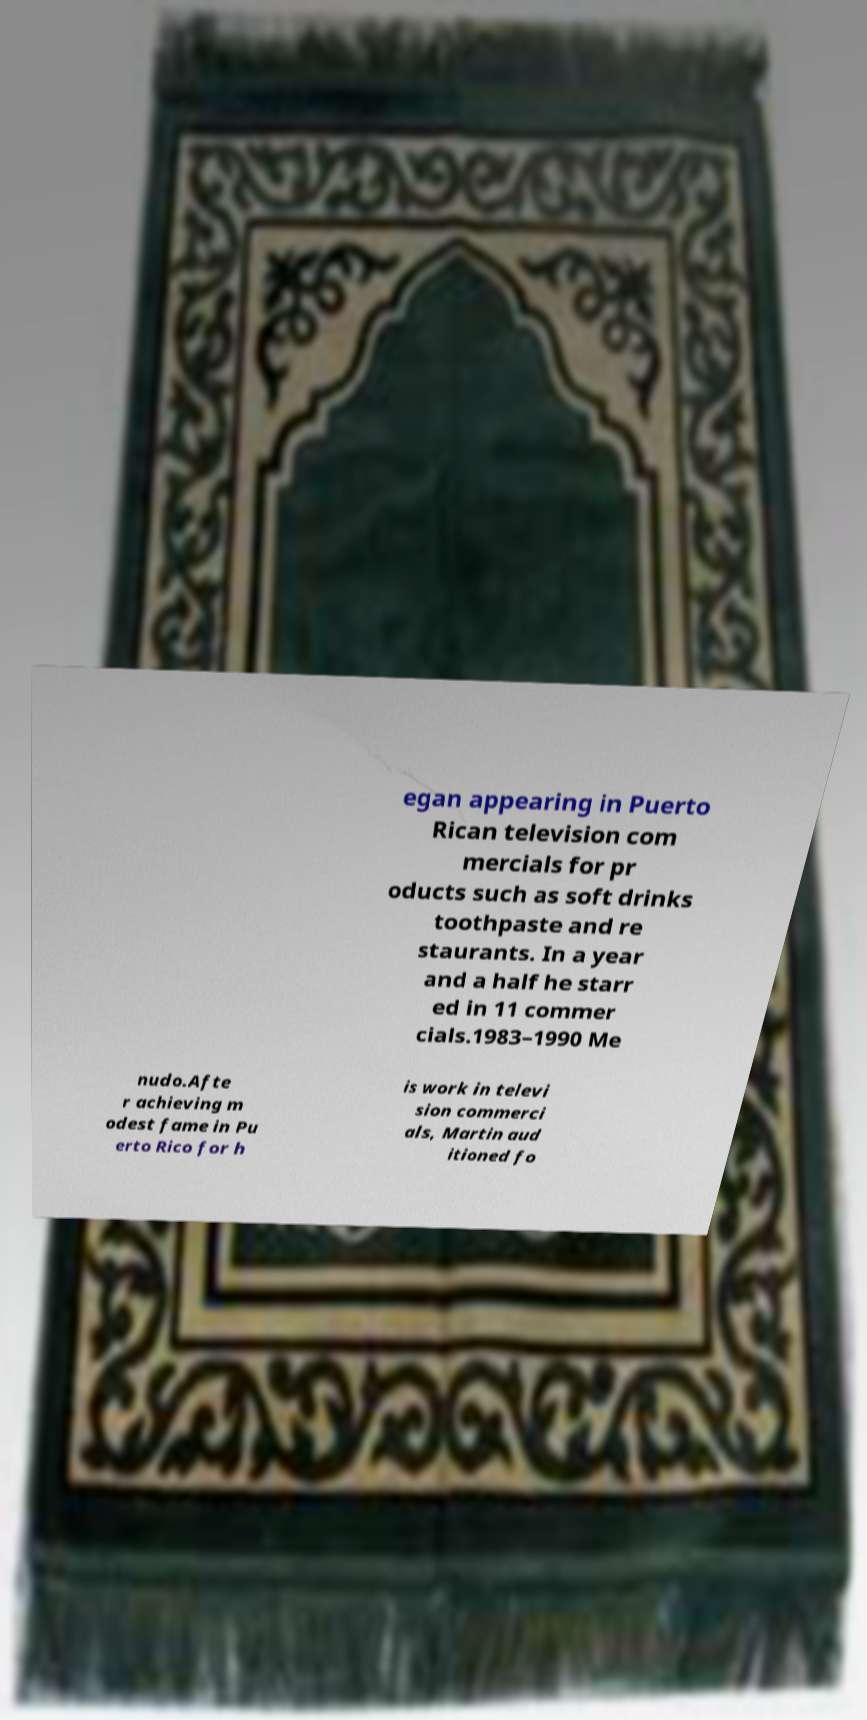Please read and relay the text visible in this image. What does it say? egan appearing in Puerto Rican television com mercials for pr oducts such as soft drinks toothpaste and re staurants. In a year and a half he starr ed in 11 commer cials.1983–1990 Me nudo.Afte r achieving m odest fame in Pu erto Rico for h is work in televi sion commerci als, Martin aud itioned fo 